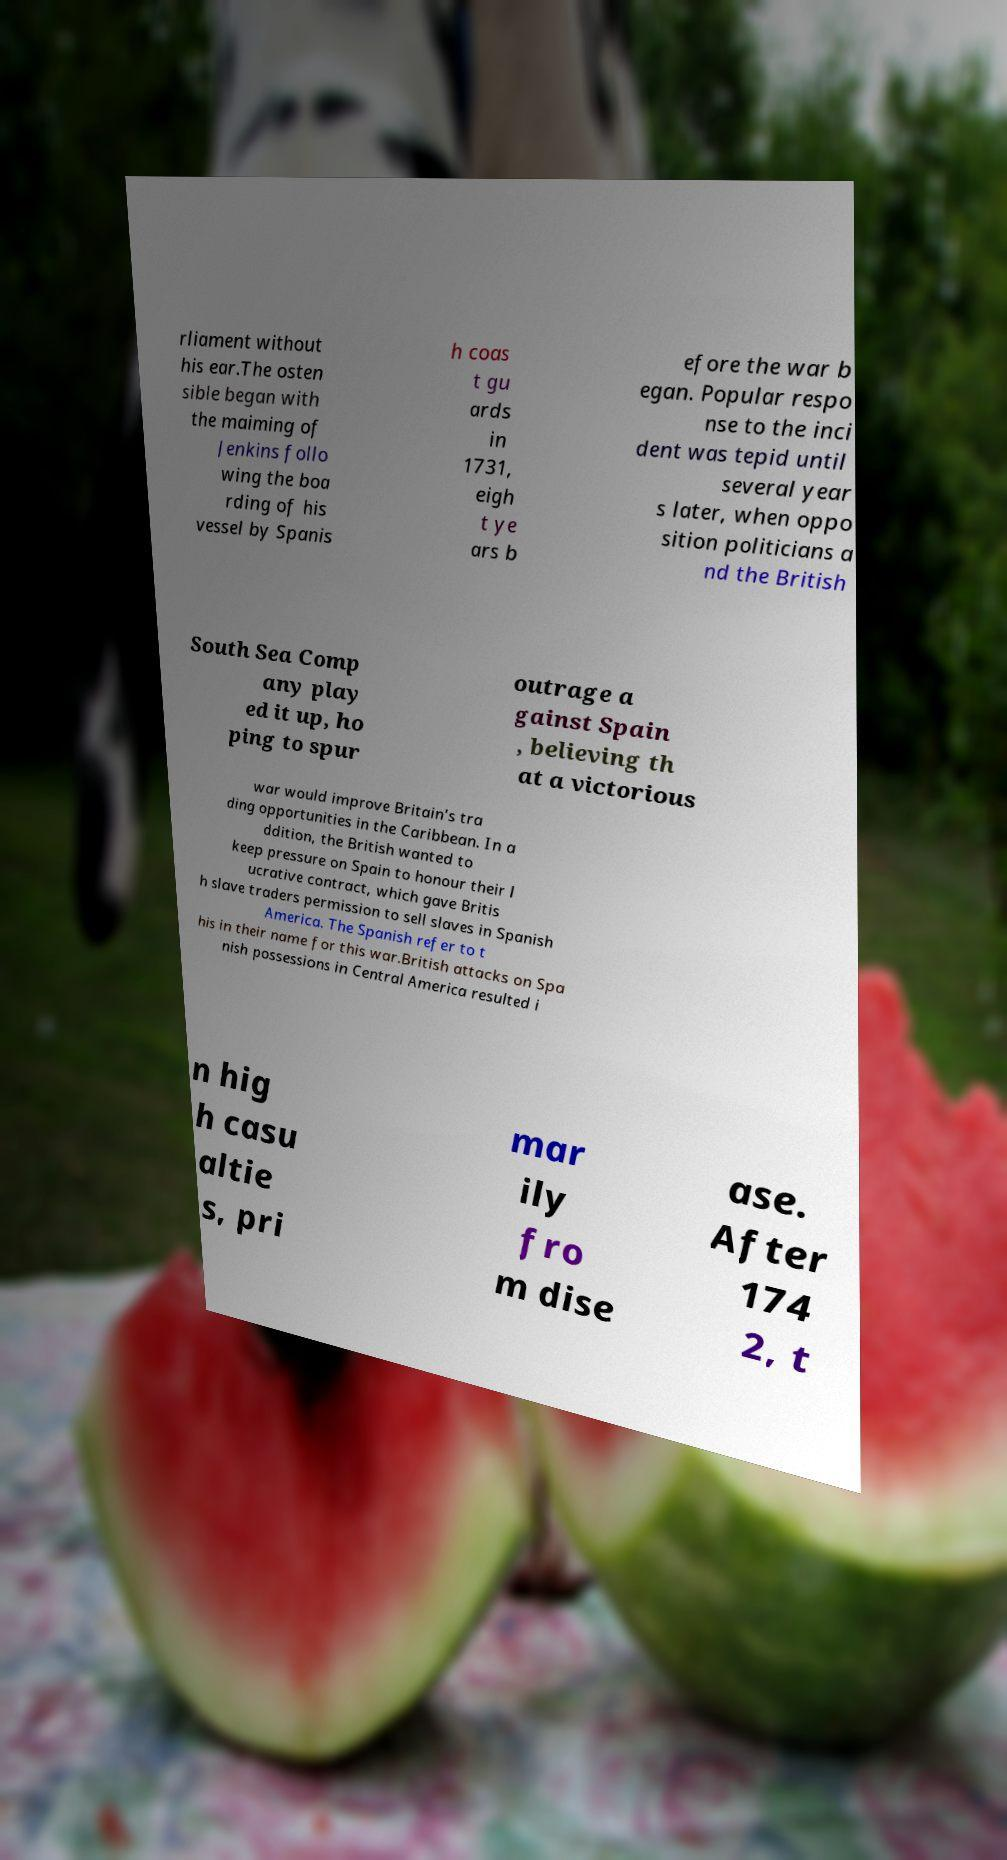For documentation purposes, I need the text within this image transcribed. Could you provide that? rliament without his ear.The osten sible began with the maiming of Jenkins follo wing the boa rding of his vessel by Spanis h coas t gu ards in 1731, eigh t ye ars b efore the war b egan. Popular respo nse to the inci dent was tepid until several year s later, when oppo sition politicians a nd the British South Sea Comp any play ed it up, ho ping to spur outrage a gainst Spain , believing th at a victorious war would improve Britain's tra ding opportunities in the Caribbean. In a ddition, the British wanted to keep pressure on Spain to honour their l ucrative contract, which gave Britis h slave traders permission to sell slaves in Spanish America. The Spanish refer to t his in their name for this war.British attacks on Spa nish possessions in Central America resulted i n hig h casu altie s, pri mar ily fro m dise ase. After 174 2, t 